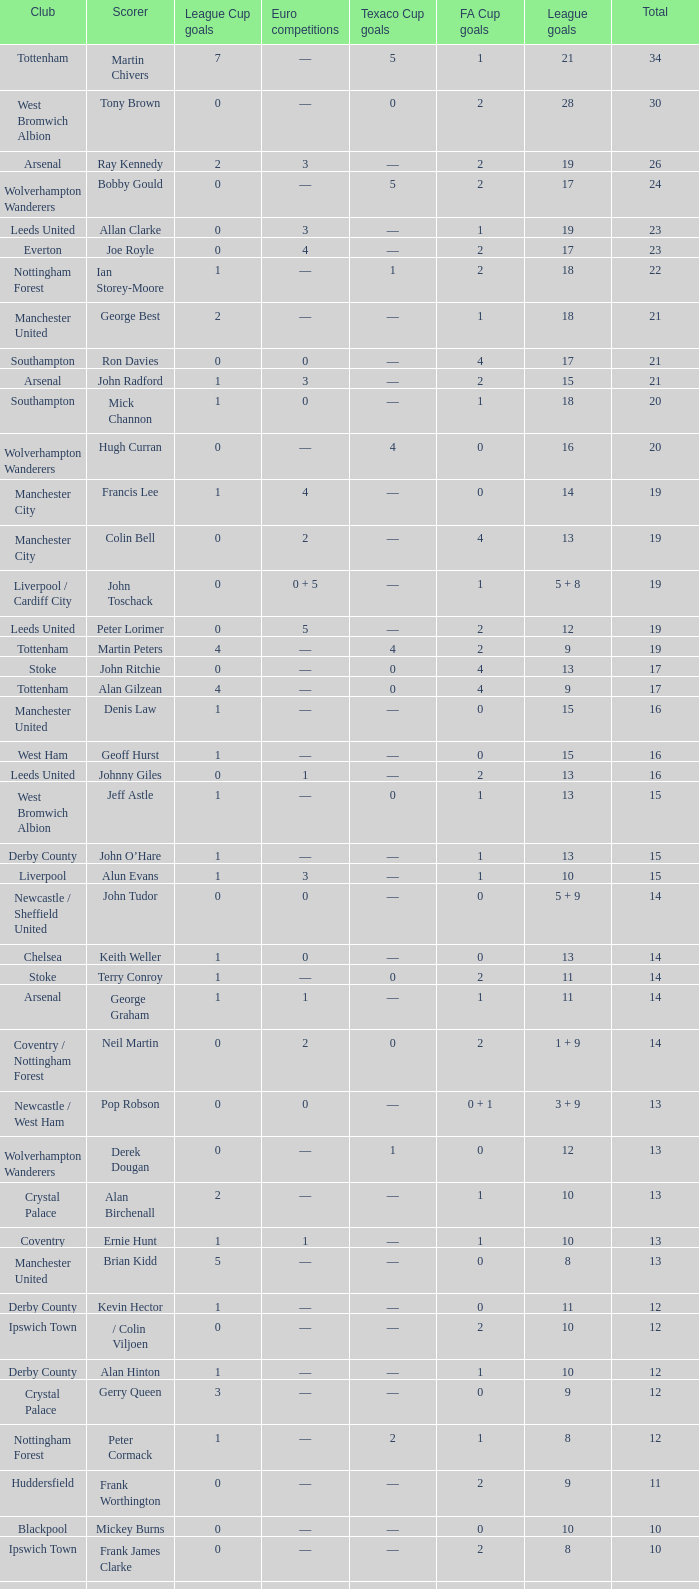What is the total number of Total, when Club is Leeds United, and when League Goals is 13? 1.0. 